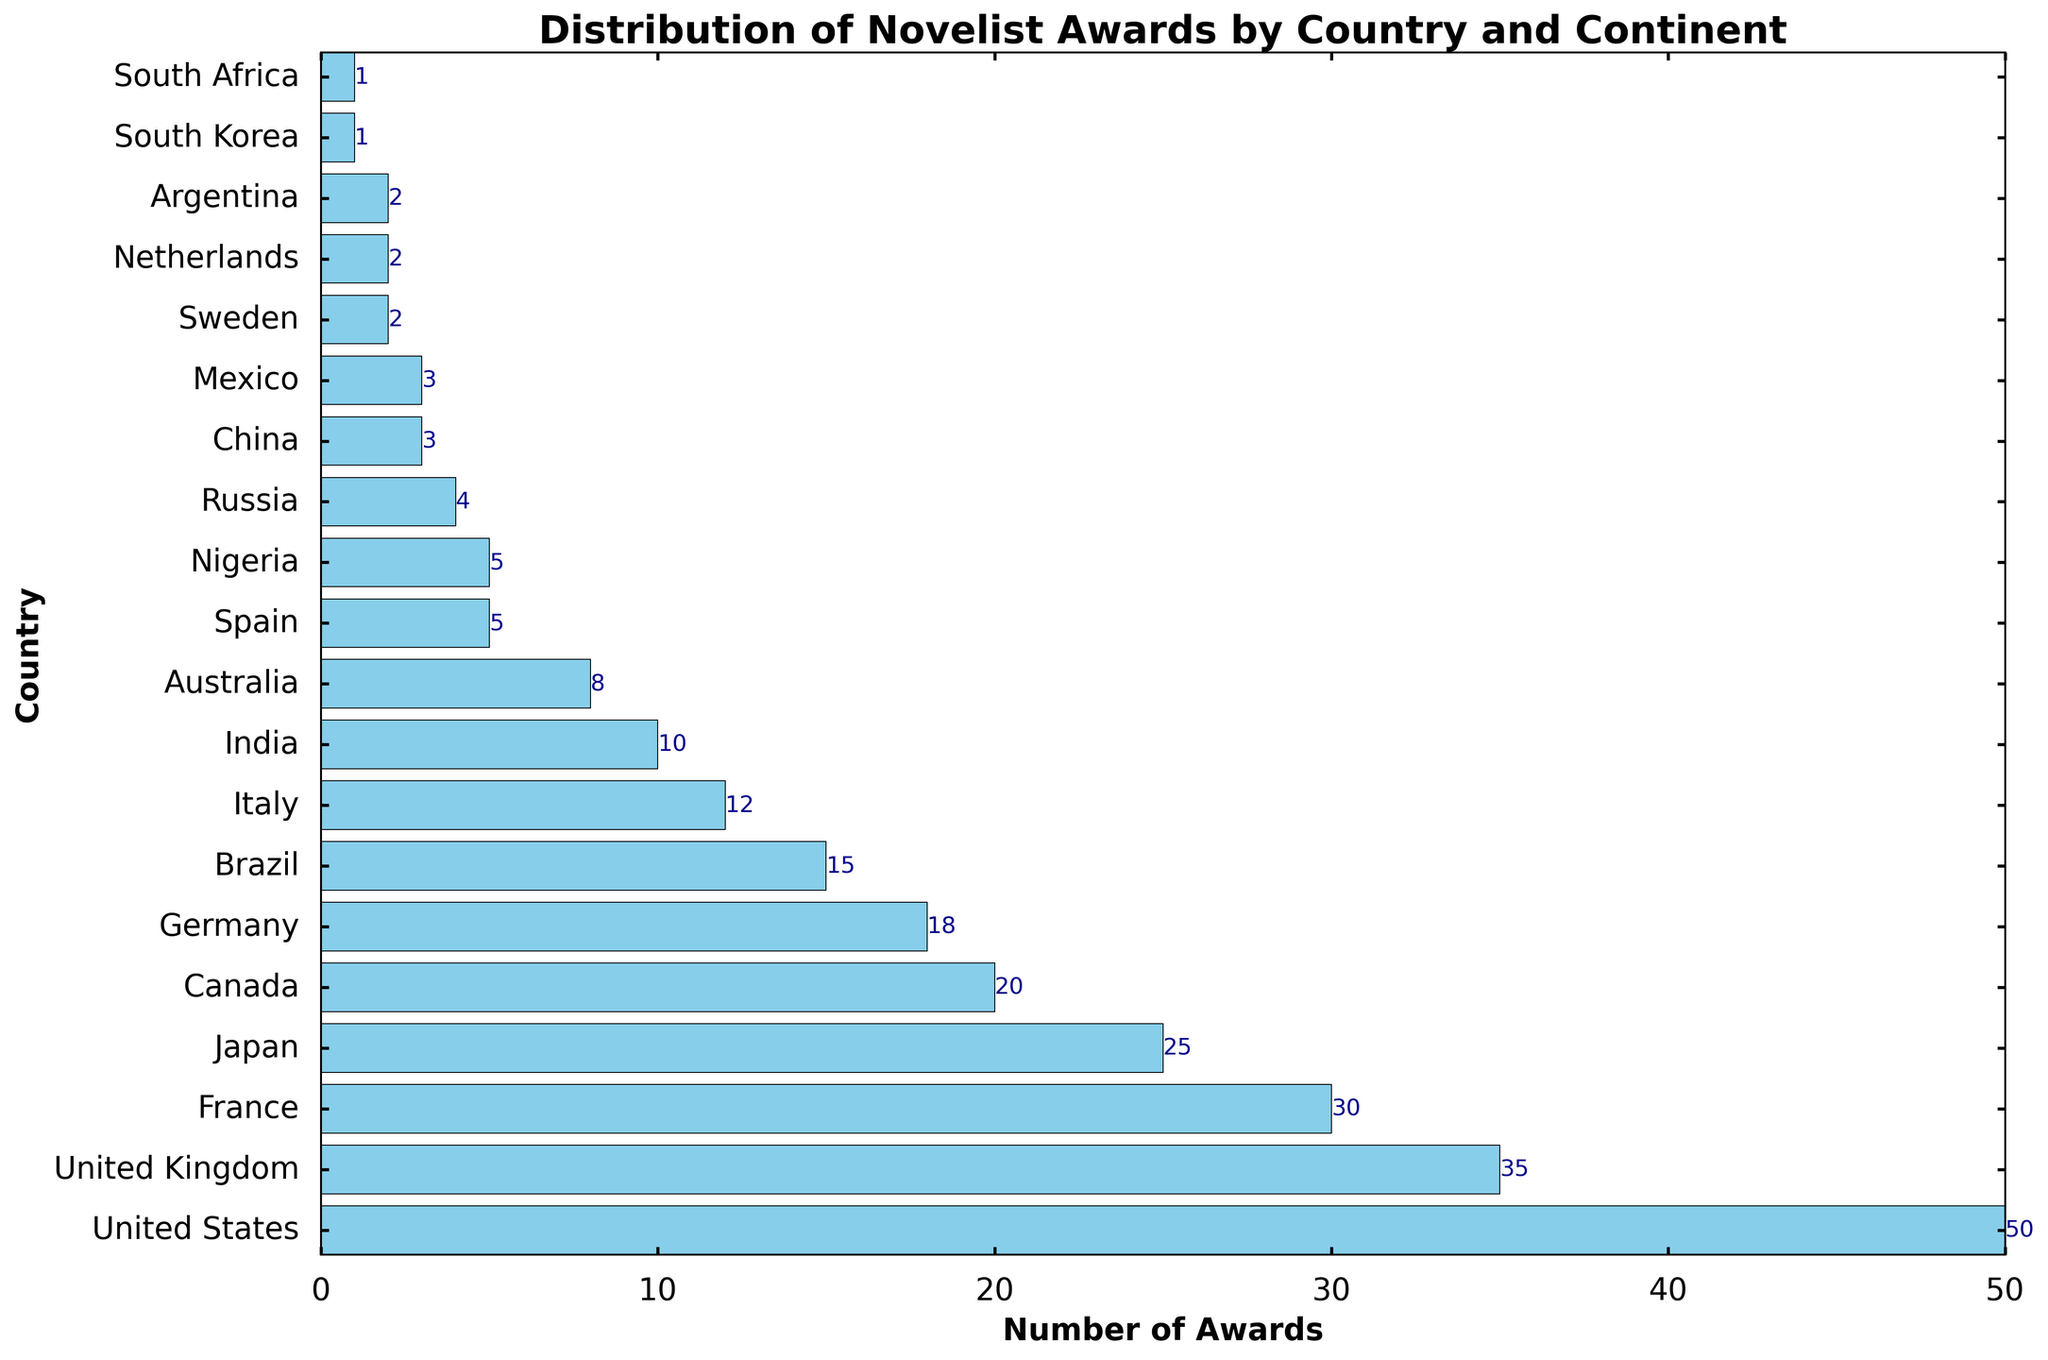Which country has the highest number of awards? The bar chart shows the length of the bars corresponding to the number of awards. The bar for the United States is the longest, indicating it has the highest number of awards.
Answer: United States Which continent has the most countries listed in the chart? By counting the countries from each continent in the bar chart, Europe appears the most frequently with several entries such as the United Kingdom, France, Germany, Italy, Spain, Russia, Sweden, and the Netherlands.
Answer: Europe What is the total number of awards given in Asia? Sum the number of awards for each country in Asia: Japan (25), India (10), China (3), South Korea (1). The total is 25 + 10 + 3 + 1 = 39.
Answer: 39 How many more awards does the United States have compared to the United Kingdom? Compare the awards for the United States (50) and the United Kingdom (35). The difference is 50 - 35 = 15.
Answer: 15 Are there any countries from Africa in the chart, and if so, which ones? Check the chart for countries marked from Africa. Two entries are evident: Nigeria with 5 awards and South Africa with 1 award.
Answer: Nigeria, South Africa Is the number of awards for Canada greater than, less than, or equal to France's number? Compare the bar lengths for Canada (20 awards) and France (30 awards). Canada has fewer awards than France.
Answer: Less than Which country in North America, other than the United States, has the most awards? In North America, aside from the United States, the countries listed are Canada with 20 awards and Mexico with 3 awards. Canada's bar is longer, indicating more awards.
Answer: Canada How many awards have been received by countries from South America? Sum the number of awards for each South American country: Brazil (15) and Argentina (2). The total is 15 + 2 = 17.
Answer: 17 Which continent is represented only once in the chart, and by what country? Oceania is represented just once in the chart, with the country Australia, which has 8 awards.
Answer: Oceania, Australia What is the difference in the number of awards between the European country with the fewest awards and the Asian country with the fewest awards? The European country with the fewest awards is the Netherlands and Sweden with 2 awards each. The Asian country with the fewest awards is South Korea with 1 award. The difference is 2 - 1 = 1.
Answer: 1 